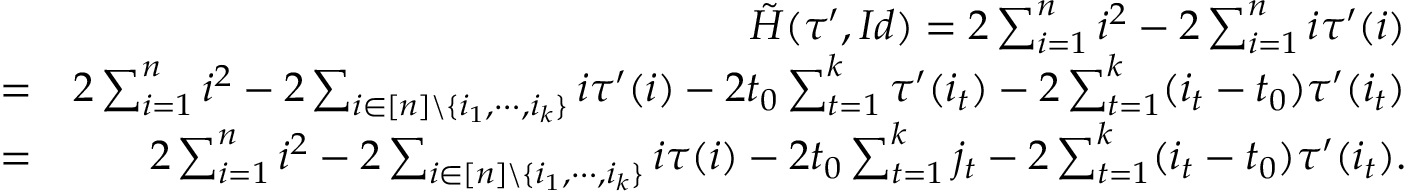Convert formula to latex. <formula><loc_0><loc_0><loc_500><loc_500>\begin{array} { r l r } & { \tilde { H } ( \tau ^ { \prime } , I d ) = 2 \sum _ { i = 1 } ^ { n } i ^ { 2 } - 2 \sum _ { i = 1 } ^ { n } i \tau ^ { \prime } ( i ) } \\ & { = } & { 2 \sum _ { i = 1 } ^ { n } i ^ { 2 } - 2 \sum _ { i \in [ n ] \ \{ i _ { 1 } , \cdots , i _ { k } \} } i \tau ^ { \prime } ( i ) - 2 t _ { 0 } \sum _ { t = 1 } ^ { k } \tau ^ { \prime } ( i _ { t } ) - 2 \sum _ { t = 1 } ^ { k } ( i _ { t } - t _ { 0 } ) \tau ^ { \prime } ( i _ { t } ) } \\ & { = } & { 2 \sum _ { i = 1 } ^ { n } i ^ { 2 } - 2 \sum _ { i \in [ n ] \ \{ i _ { 1 } , \cdots , i _ { k } \} } i \tau ( i ) - 2 t _ { 0 } \sum _ { t = 1 } ^ { k } j _ { t } - 2 \sum _ { t = 1 } ^ { k } ( i _ { t } - t _ { 0 } ) \tau ^ { \prime } ( i _ { t } ) . } \end{array}</formula> 